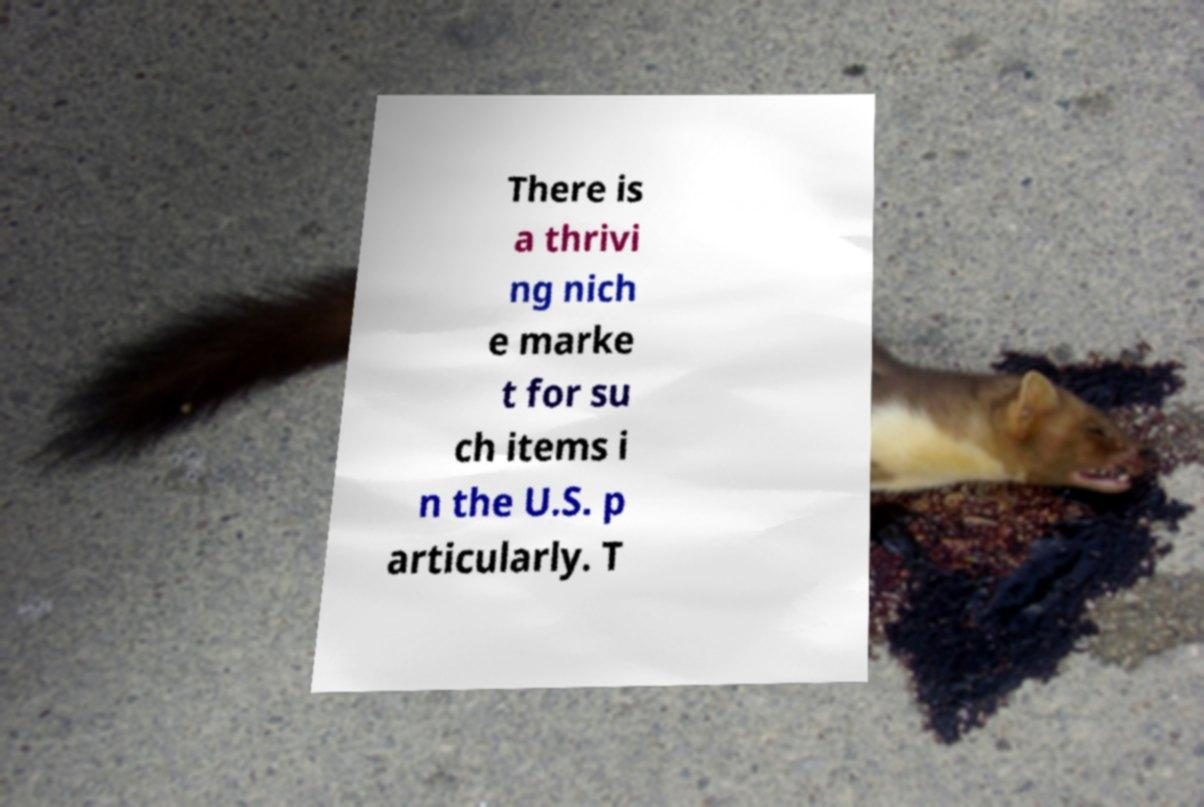Can you read and provide the text displayed in the image?This photo seems to have some interesting text. Can you extract and type it out for me? There is a thrivi ng nich e marke t for su ch items i n the U.S. p articularly. T 